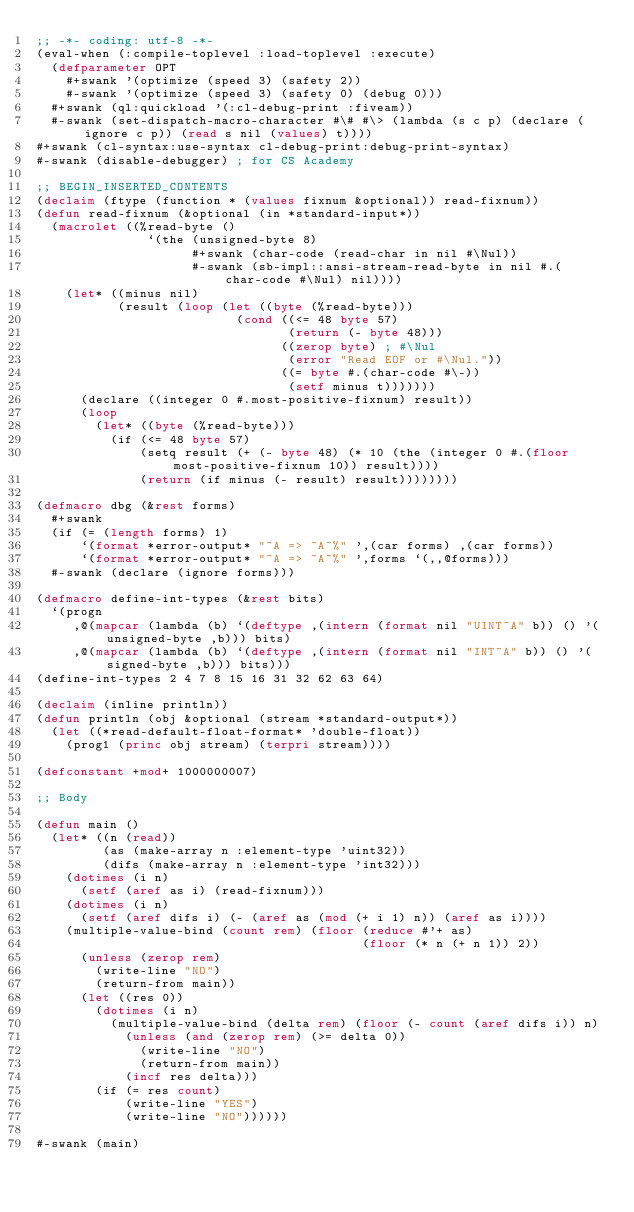Convert code to text. <code><loc_0><loc_0><loc_500><loc_500><_Lisp_>;; -*- coding: utf-8 -*-
(eval-when (:compile-toplevel :load-toplevel :execute)
  (defparameter OPT
    #+swank '(optimize (speed 3) (safety 2))
    #-swank '(optimize (speed 3) (safety 0) (debug 0)))
  #+swank (ql:quickload '(:cl-debug-print :fiveam))
  #-swank (set-dispatch-macro-character #\# #\> (lambda (s c p) (declare (ignore c p)) (read s nil (values) t))))
#+swank (cl-syntax:use-syntax cl-debug-print:debug-print-syntax)
#-swank (disable-debugger) ; for CS Academy

;; BEGIN_INSERTED_CONTENTS
(declaim (ftype (function * (values fixnum &optional)) read-fixnum))
(defun read-fixnum (&optional (in *standard-input*))
  (macrolet ((%read-byte ()
               `(the (unsigned-byte 8)
                     #+swank (char-code (read-char in nil #\Nul))
                     #-swank (sb-impl::ansi-stream-read-byte in nil #.(char-code #\Nul) nil))))
    (let* ((minus nil)
           (result (loop (let ((byte (%read-byte)))
                           (cond ((<= 48 byte 57)
                                  (return (- byte 48)))
                                 ((zerop byte) ; #\Nul
                                  (error "Read EOF or #\Nul."))
                                 ((= byte #.(char-code #\-))
                                  (setf minus t)))))))
      (declare ((integer 0 #.most-positive-fixnum) result))
      (loop
        (let* ((byte (%read-byte)))
          (if (<= 48 byte 57)
              (setq result (+ (- byte 48) (* 10 (the (integer 0 #.(floor most-positive-fixnum 10)) result))))
              (return (if minus (- result) result))))))))

(defmacro dbg (&rest forms)
  #+swank
  (if (= (length forms) 1)
      `(format *error-output* "~A => ~A~%" ',(car forms) ,(car forms))
      `(format *error-output* "~A => ~A~%" ',forms `(,,@forms)))
  #-swank (declare (ignore forms)))

(defmacro define-int-types (&rest bits)
  `(progn
     ,@(mapcar (lambda (b) `(deftype ,(intern (format nil "UINT~A" b)) () '(unsigned-byte ,b))) bits)
     ,@(mapcar (lambda (b) `(deftype ,(intern (format nil "INT~A" b)) () '(signed-byte ,b))) bits)))
(define-int-types 2 4 7 8 15 16 31 32 62 63 64)

(declaim (inline println))
(defun println (obj &optional (stream *standard-output*))
  (let ((*read-default-float-format* 'double-float))
    (prog1 (princ obj stream) (terpri stream))))

(defconstant +mod+ 1000000007)

;; Body

(defun main ()
  (let* ((n (read))
         (as (make-array n :element-type 'uint32))
         (difs (make-array n :element-type 'int32)))
    (dotimes (i n)
      (setf (aref as i) (read-fixnum)))
    (dotimes (i n)
      (setf (aref difs i) (- (aref as (mod (+ i 1) n)) (aref as i))))
    (multiple-value-bind (count rem) (floor (reduce #'+ as)
                                            (floor (* n (+ n 1)) 2))
      (unless (zerop rem)
        (write-line "NO")
        (return-from main))
      (let ((res 0))
        (dotimes (i n)
          (multiple-value-bind (delta rem) (floor (- count (aref difs i)) n)
            (unless (and (zerop rem) (>= delta 0))
              (write-line "NO")
              (return-from main))
            (incf res delta)))
        (if (= res count)
            (write-line "YES")
            (write-line "NO"))))))

#-swank (main)
</code> 